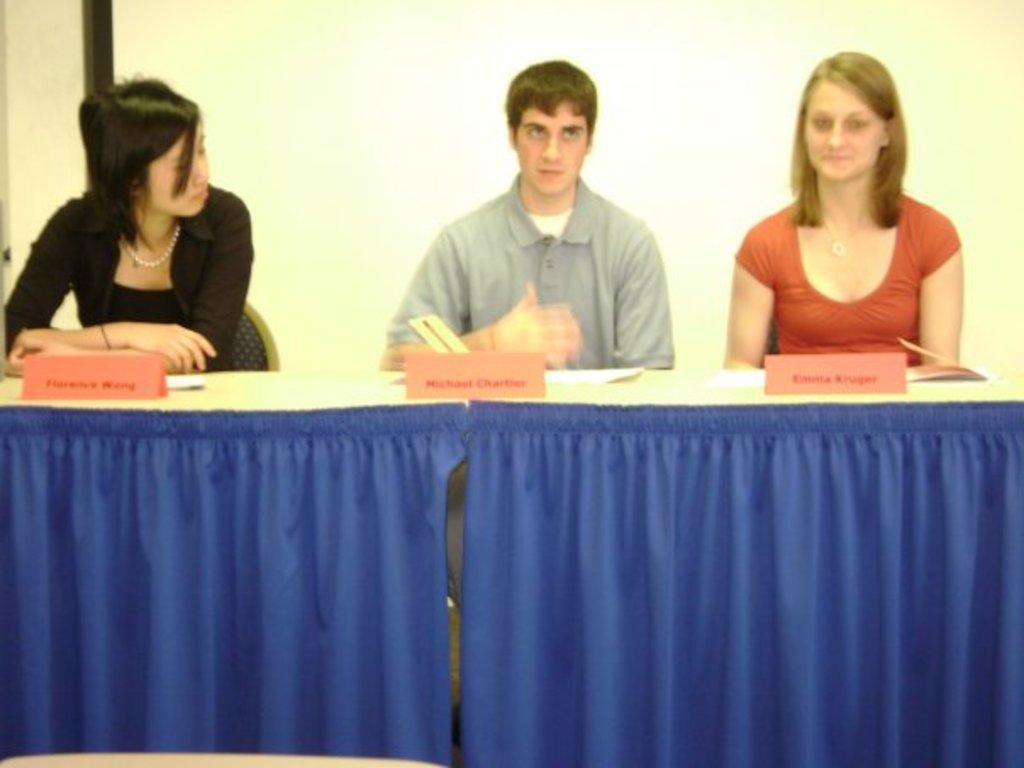How many people are in the image? There are two women and a man in the image, making a total of three people. What are the people doing in the image? They are standing in front of a table. What can be seen on the table? There are name boards on the table. What type of tree is growing in the middle of the table? There is no tree present on the table in the image. Can you describe the body language of the people in the image? The provided facts do not include information about the body language of the people in the image. 